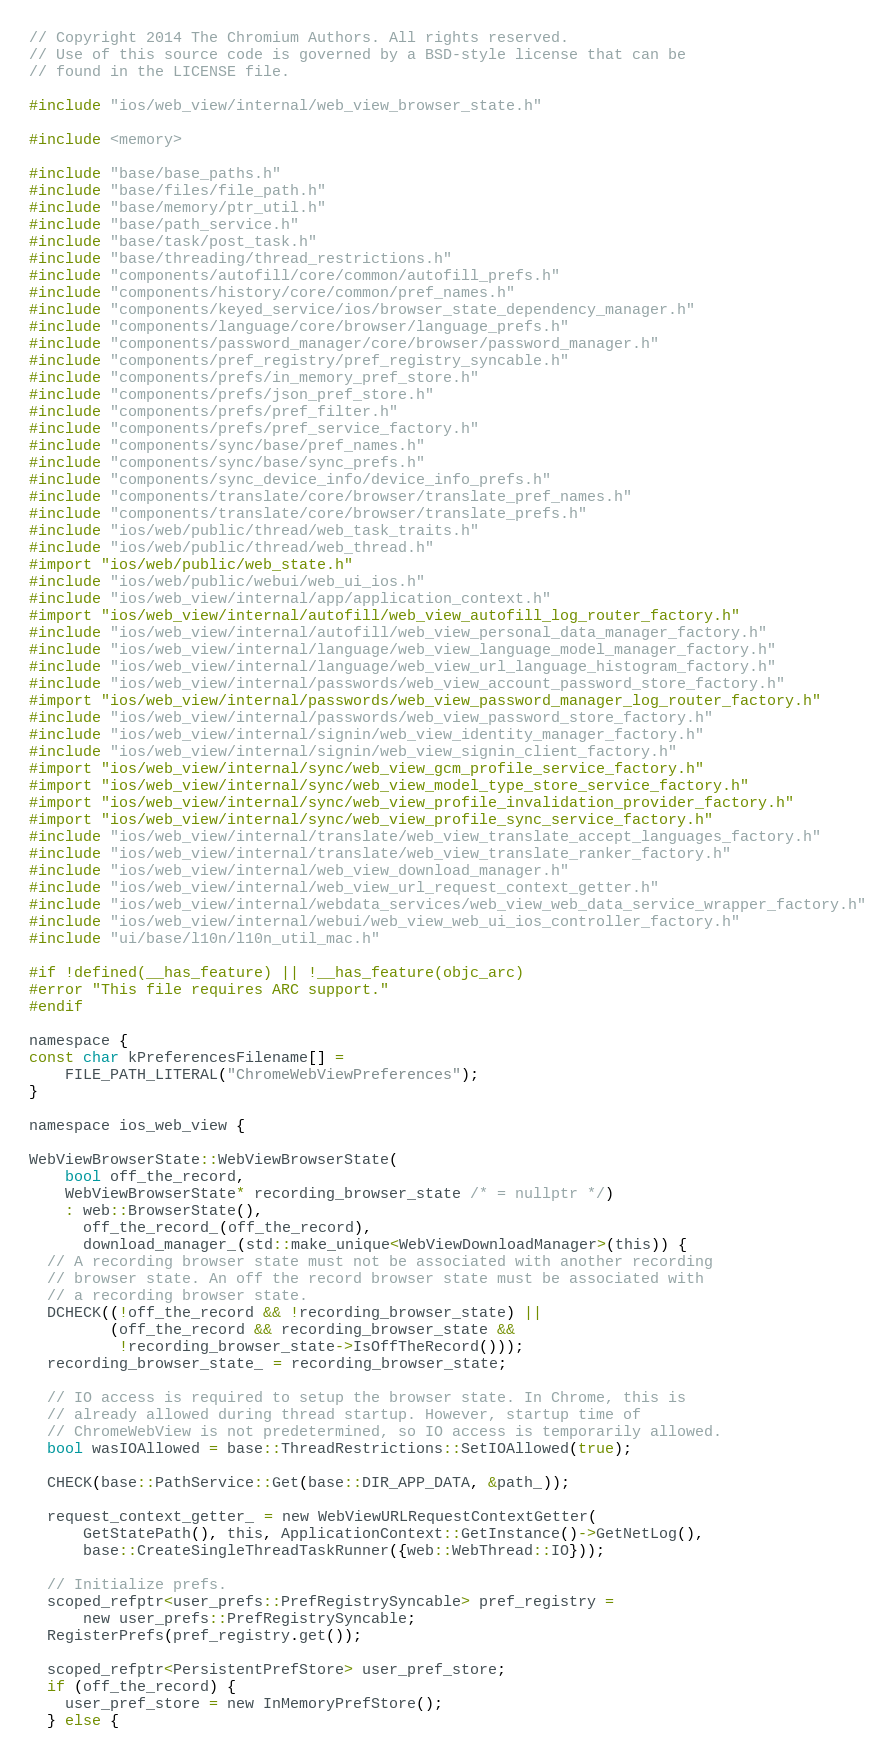Convert code to text. <code><loc_0><loc_0><loc_500><loc_500><_ObjectiveC_>// Copyright 2014 The Chromium Authors. All rights reserved.
// Use of this source code is governed by a BSD-style license that can be
// found in the LICENSE file.

#include "ios/web_view/internal/web_view_browser_state.h"

#include <memory>

#include "base/base_paths.h"
#include "base/files/file_path.h"
#include "base/memory/ptr_util.h"
#include "base/path_service.h"
#include "base/task/post_task.h"
#include "base/threading/thread_restrictions.h"
#include "components/autofill/core/common/autofill_prefs.h"
#include "components/history/core/common/pref_names.h"
#include "components/keyed_service/ios/browser_state_dependency_manager.h"
#include "components/language/core/browser/language_prefs.h"
#include "components/password_manager/core/browser/password_manager.h"
#include "components/pref_registry/pref_registry_syncable.h"
#include "components/prefs/in_memory_pref_store.h"
#include "components/prefs/json_pref_store.h"
#include "components/prefs/pref_filter.h"
#include "components/prefs/pref_service_factory.h"
#include "components/sync/base/pref_names.h"
#include "components/sync/base/sync_prefs.h"
#include "components/sync_device_info/device_info_prefs.h"
#include "components/translate/core/browser/translate_pref_names.h"
#include "components/translate/core/browser/translate_prefs.h"
#include "ios/web/public/thread/web_task_traits.h"
#include "ios/web/public/thread/web_thread.h"
#import "ios/web/public/web_state.h"
#include "ios/web/public/webui/web_ui_ios.h"
#include "ios/web_view/internal/app/application_context.h"
#import "ios/web_view/internal/autofill/web_view_autofill_log_router_factory.h"
#include "ios/web_view/internal/autofill/web_view_personal_data_manager_factory.h"
#include "ios/web_view/internal/language/web_view_language_model_manager_factory.h"
#include "ios/web_view/internal/language/web_view_url_language_histogram_factory.h"
#include "ios/web_view/internal/passwords/web_view_account_password_store_factory.h"
#import "ios/web_view/internal/passwords/web_view_password_manager_log_router_factory.h"
#include "ios/web_view/internal/passwords/web_view_password_store_factory.h"
#include "ios/web_view/internal/signin/web_view_identity_manager_factory.h"
#include "ios/web_view/internal/signin/web_view_signin_client_factory.h"
#import "ios/web_view/internal/sync/web_view_gcm_profile_service_factory.h"
#import "ios/web_view/internal/sync/web_view_model_type_store_service_factory.h"
#import "ios/web_view/internal/sync/web_view_profile_invalidation_provider_factory.h"
#import "ios/web_view/internal/sync/web_view_profile_sync_service_factory.h"
#include "ios/web_view/internal/translate/web_view_translate_accept_languages_factory.h"
#include "ios/web_view/internal/translate/web_view_translate_ranker_factory.h"
#include "ios/web_view/internal/web_view_download_manager.h"
#include "ios/web_view/internal/web_view_url_request_context_getter.h"
#include "ios/web_view/internal/webdata_services/web_view_web_data_service_wrapper_factory.h"
#include "ios/web_view/internal/webui/web_view_web_ui_ios_controller_factory.h"
#include "ui/base/l10n/l10n_util_mac.h"

#if !defined(__has_feature) || !__has_feature(objc_arc)
#error "This file requires ARC support."
#endif

namespace {
const char kPreferencesFilename[] =
    FILE_PATH_LITERAL("ChromeWebViewPreferences");
}

namespace ios_web_view {

WebViewBrowserState::WebViewBrowserState(
    bool off_the_record,
    WebViewBrowserState* recording_browser_state /* = nullptr */)
    : web::BrowserState(),
      off_the_record_(off_the_record),
      download_manager_(std::make_unique<WebViewDownloadManager>(this)) {
  // A recording browser state must not be associated with another recording
  // browser state. An off the record browser state must be associated with
  // a recording browser state.
  DCHECK((!off_the_record && !recording_browser_state) ||
         (off_the_record && recording_browser_state &&
          !recording_browser_state->IsOffTheRecord()));
  recording_browser_state_ = recording_browser_state;

  // IO access is required to setup the browser state. In Chrome, this is
  // already allowed during thread startup. However, startup time of
  // ChromeWebView is not predetermined, so IO access is temporarily allowed.
  bool wasIOAllowed = base::ThreadRestrictions::SetIOAllowed(true);

  CHECK(base::PathService::Get(base::DIR_APP_DATA, &path_));

  request_context_getter_ = new WebViewURLRequestContextGetter(
      GetStatePath(), this, ApplicationContext::GetInstance()->GetNetLog(),
      base::CreateSingleThreadTaskRunner({web::WebThread::IO}));

  // Initialize prefs.
  scoped_refptr<user_prefs::PrefRegistrySyncable> pref_registry =
      new user_prefs::PrefRegistrySyncable;
  RegisterPrefs(pref_registry.get());

  scoped_refptr<PersistentPrefStore> user_pref_store;
  if (off_the_record) {
    user_pref_store = new InMemoryPrefStore();
  } else {</code> 